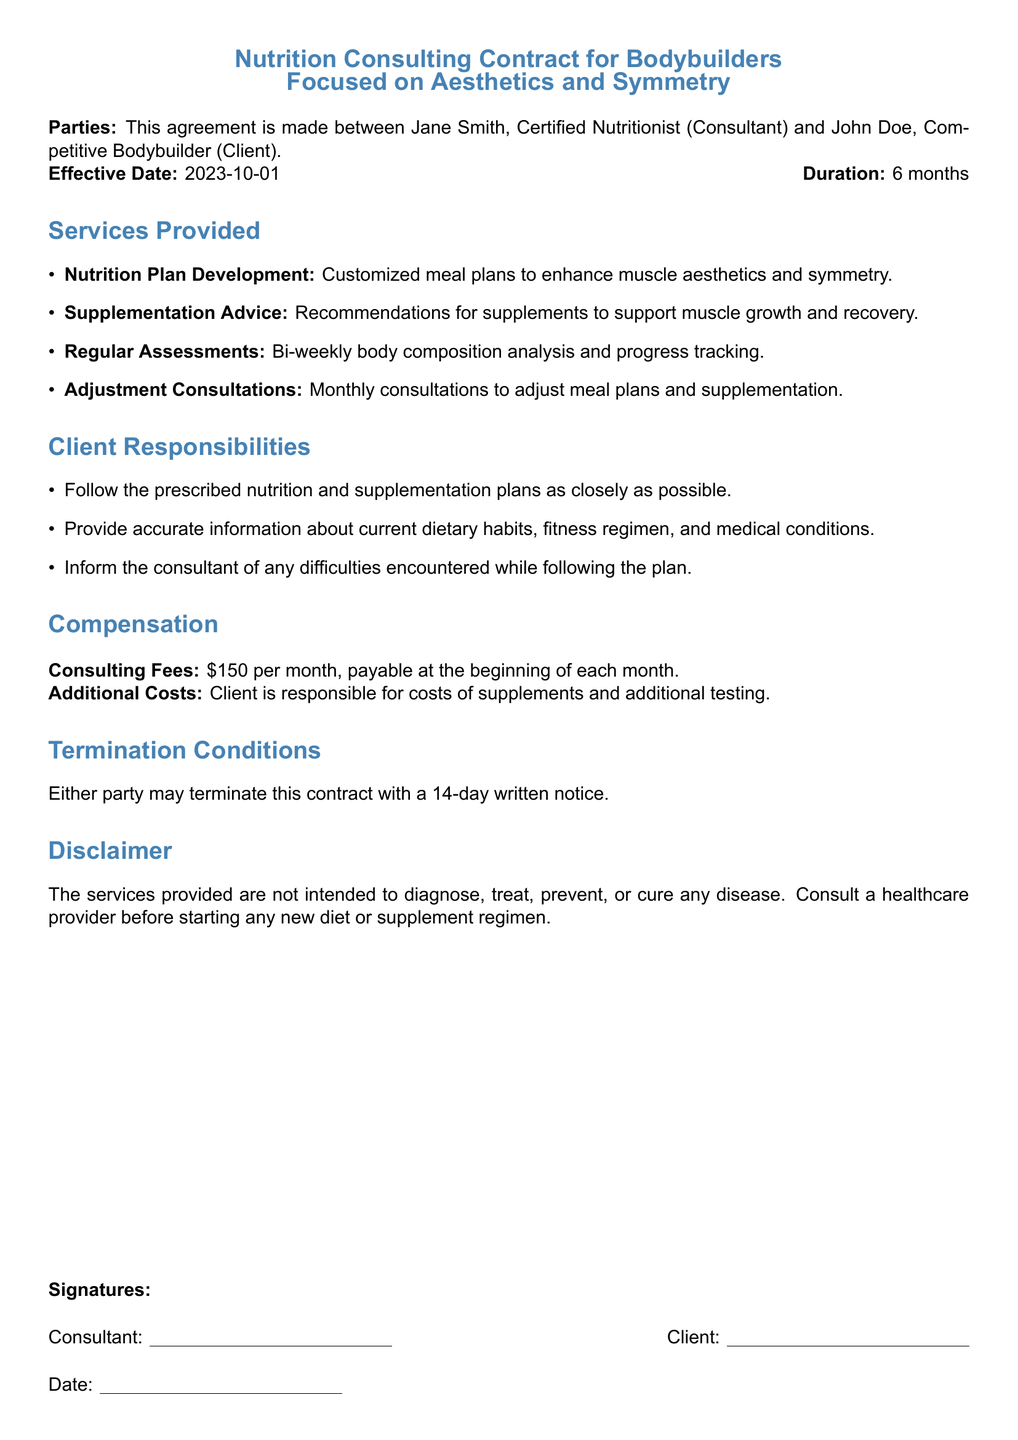What is the effective date of the contract? The effective date is specified in the document as when the contract starts.
Answer: 2023-10-01 How long is the duration of the contract? The document states the duration, indicating how long the agreement is valid.
Answer: 6 months Who is the consultant in this contract? The document lists the consultant's name and title at the beginning.
Answer: Jane Smith What is the consulting fee per month? The fee is mentioned in the compensation section, indicating the financial terms.
Answer: $150 How often will there be assessments? The document describes the frequency of the assessments in the services provided section.
Answer: Bi-weekly What must the client inform the consultant about? The client responsibilities section mentions specific duties the client has towards the consultant.
Answer: Difficulties encountered Under what condition can the contract be terminated? The document specifies how and when either party may terminate the contract.
Answer: 14-day written notice What must the client provide to the consultant? The client responsibilities section outlines what the client must offer for the consultation to be effective.
Answer: Accurate information Is the consultant allowed to diagnose diseases? The disclaimer section clarifies the scope of the services provided by the consultant.
Answer: No 